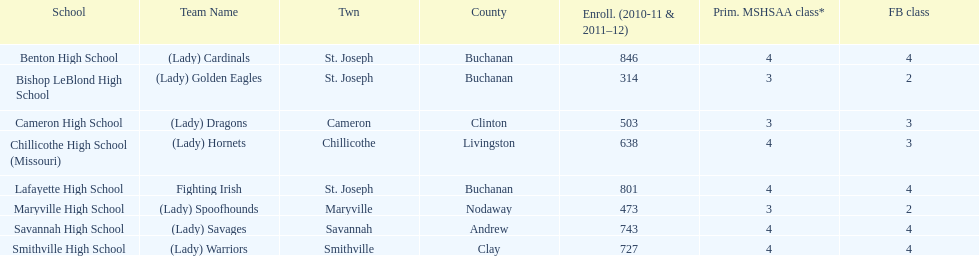How many teams are named after birds? 2. 